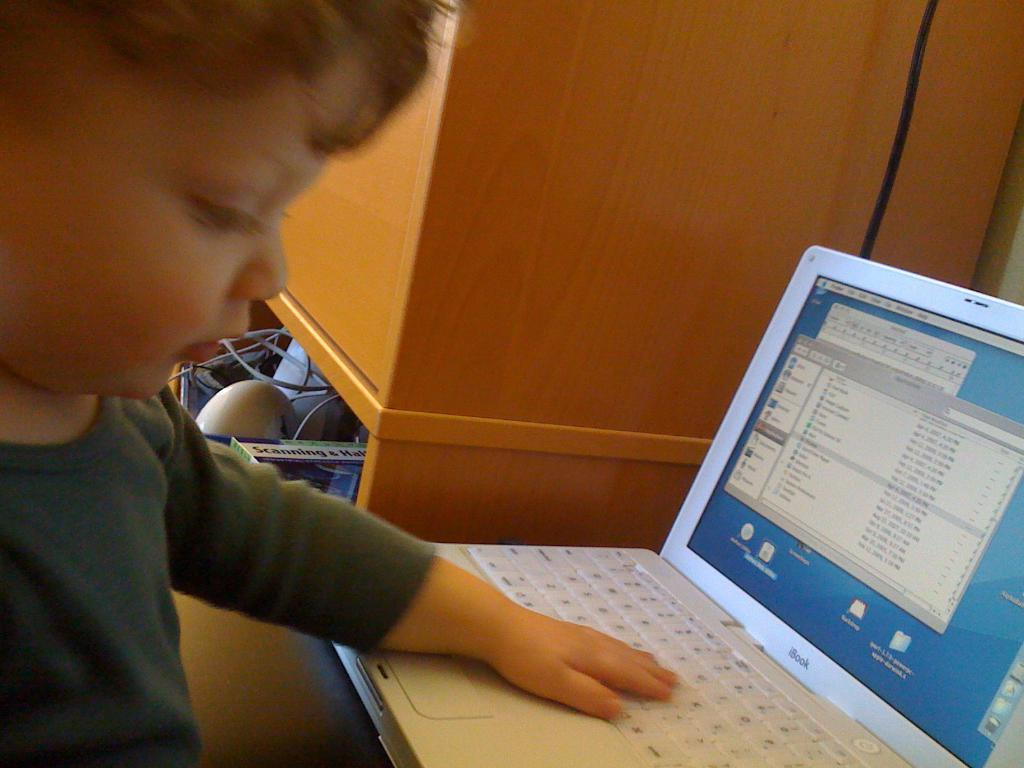What is the main subject in the foreground of the picture? There is a boy in the foreground of the picture. What is the boy doing in the picture? The boy has his hand on a laptop. What can be seen in the background of the picture? There is a cupboard and other objects visible in the background of the picture. How many oranges are being exchanged in the cent of the image? There are no oranges or any exchange taking place in the image. 